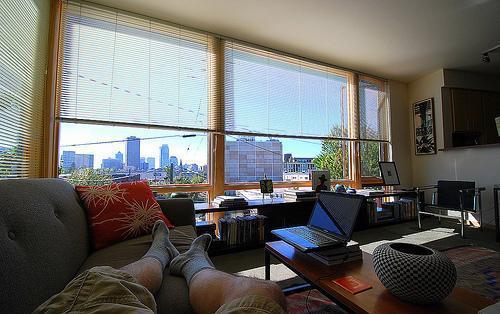How many people are in the photo?
Give a very brief answer. 1. How many window blinds are pulled up?
Give a very brief answer. 3. 